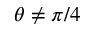<formula> <loc_0><loc_0><loc_500><loc_500>\theta \neq \pi / 4</formula> 